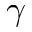<formula> <loc_0><loc_0><loc_500><loc_500>\gamma</formula> 